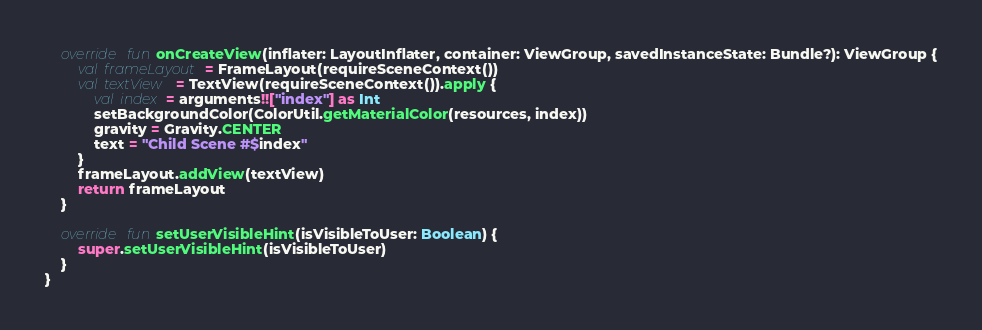Convert code to text. <code><loc_0><loc_0><loc_500><loc_500><_Kotlin_>    override fun onCreateView(inflater: LayoutInflater, container: ViewGroup, savedInstanceState: Bundle?): ViewGroup {
        val frameLayout = FrameLayout(requireSceneContext())
        val textView = TextView(requireSceneContext()).apply {
            val index = arguments!!["index"] as Int
            setBackgroundColor(ColorUtil.getMaterialColor(resources, index))
            gravity = Gravity.CENTER
            text = "Child Scene #$index"
        }
        frameLayout.addView(textView)
        return frameLayout
    }

    override fun setUserVisibleHint(isVisibleToUser: Boolean) {
        super.setUserVisibleHint(isVisibleToUser)
    }
}</code> 